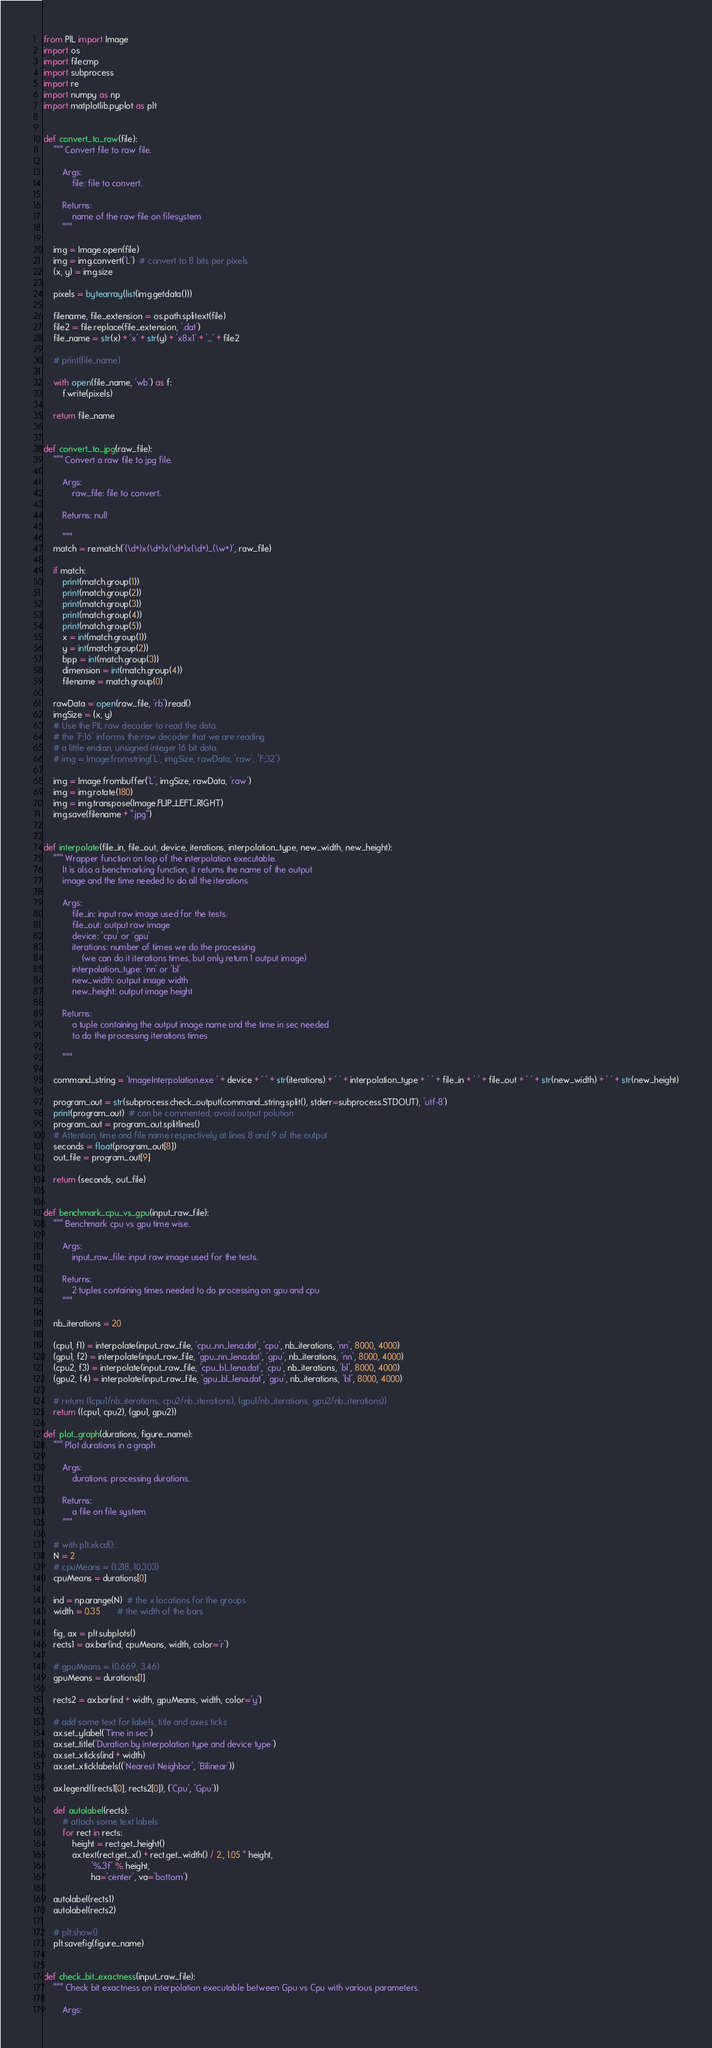Convert code to text. <code><loc_0><loc_0><loc_500><loc_500><_Python_>from PIL import Image
import os
import filecmp
import subprocess
import re
import numpy as np
import matplotlib.pyplot as plt


def convert_to_raw(file):
    """ Convert file to raw file.

        Args:
            file: file to convert.

        Returns:
            name of the raw file on filesystem
        """

    img = Image.open(file)
    img = img.convert('L')  # convert to 8 bits per pixels
    (x, y) = img.size

    pixels = bytearray(list(img.getdata()))

    filename, file_extension = os.path.splitext(file)
    file2 = file.replace(file_extension, '.dat')
    file_name = str(x) + 'x' + str(y) + 'x8x1' + '_' + file2

    # print(file_name)

    with open(file_name, 'wb') as f:
        f.write(pixels)

    return file_name


def convert_to_jpg(raw_file):
    """ Convert a raw file to jpg file.

        Args:
            raw_file: file to convert.

        Returns: null

        """
    match = re.match('(\d+)x(\d+)x(\d+)x(\d+)_(\w+)', raw_file)

    if match:
        print(match.group(1))
        print(match.group(2))
        print(match.group(3))
        print(match.group(4))
        print(match.group(5))
        x = int(match.group(1))
        y = int(match.group(2))
        bpp = int(match.group(3))
        dimension = int(match.group(4))
        filename = match.group(0)

    rawData = open(raw_file, 'rb').read()
    imgSize = (x, y)
    # Use the PIL raw decoder to read the data.
    # the 'F;16' informs the raw decoder that we are reading
    # a little endian, unsigned integer 16 bit data.
    # img = Image.fromstring('L', imgSize, rawData, 'raw', 'F;32')

    img = Image.frombuffer('L', imgSize, rawData, 'raw')
    img = img.rotate(180)
    img = img.transpose(Image.FLIP_LEFT_RIGHT)
    img.save(filename + ".jpg")


def interpolate(file_in, file_out, device, iterations, interpolation_type, new_width, new_height):
    """ Wrapper function on top of the interpolation executable.
        It is also a benchmarking function, it returns the name of the output
        image and the time needed to do all the iterations

        Args:
            file_in: input raw image used for the tests.
            file_out: output raw image
            device: 'cpu' or 'gpu'
            iterations: number of times we do the processing
                (we can do it iterations times, but only return 1 output image)
            interpolation_type: 'nn' or 'bl'
            new_width: output image width
            new_height: output image height

        Returns:
            a tuple containing the output image name and the time in sec needed
            to do the processing iterations times

        """

    command_string = 'ImageInterpolation.exe ' + device + ' ' + str(iterations) + ' ' + interpolation_type + ' ' + file_in + ' ' + file_out + ' ' + str(new_width) + ' ' + str(new_height)

    program_out = str(subprocess.check_output(command_string.split(), stderr=subprocess.STDOUT), 'utf-8')
    print(program_out)  # can be commented, avoid output polution
    program_out = program_out.splitlines()
    # Attention, time and file name respectively at lines 8 and 9 of the output
    seconds = float(program_out[8])
    out_file = program_out[9]

    return (seconds, out_file)


def benchmark_cpu_vs_gpu(input_raw_file):
    """ Benchmark cpu vs gpu time wise.

        Args:
            input_raw_file: input raw image used for the tests.

        Returns:
            2 tuples containing times needed to do processing on gpu and cpu
        """

    nb_iterations = 20

    (cpu1, f1) = interpolate(input_raw_file, 'cpu_nn_lena.dat', 'cpu', nb_iterations, 'nn', 8000, 4000)
    (gpu1, f2) = interpolate(input_raw_file, 'gpu_nn_lena.dat', 'gpu', nb_iterations, 'nn', 8000, 4000)
    (cpu2, f3) = interpolate(input_raw_file, 'cpu_bl_lena.dat', 'cpu', nb_iterations, 'bl', 8000, 4000)
    (gpu2, f4) = interpolate(input_raw_file, 'gpu_bl_lena.dat', 'gpu', nb_iterations, 'bl', 8000, 4000)

    # return ((cpu1/nb_iterations, cpu2/nb_iterations), (gpu1/nb_iterations, gpu2/nb_iterations))
    return ((cpu1, cpu2), (gpu1, gpu2))

def plot_graph(durations, figure_name):
    """ Plot durations in a graph

        Args:
            durations: processing durations.

        Returns:
            a file on file system
        """

    # with plt.xkcd():
    N = 2
    # cpuMeans = (1.218, 10.303)
    cpuMeans = durations[0]

    ind = np.arange(N)  # the x locations for the groups
    width = 0.35       # the width of the bars

    fig, ax = plt.subplots()
    rects1 = ax.bar(ind, cpuMeans, width, color='r')

    # gpuMeans = (0.669, 3.46)
    gpuMeans = durations[1]

    rects2 = ax.bar(ind + width, gpuMeans, width, color='y')

    # add some text for labels, title and axes ticks
    ax.set_ylabel('Time in sec')
    ax.set_title('Duration by interpolation type and device type')
    ax.set_xticks(ind + width)
    ax.set_xticklabels(('Nearest Neighbor', 'Bilinear'))

    ax.legend((rects1[0], rects2[0]), ('Cpu', 'Gpu'))

    def autolabel(rects):
        # attach some text labels
        for rect in rects:
            height = rect.get_height()
            ax.text(rect.get_x() + rect.get_width() / 2., 1.05 * height,
                    '%.3f' % height,
                    ha='center', va='bottom')

    autolabel(rects1)
    autolabel(rects2)

    # plt.show()
    plt.savefig(figure_name)


def check_bit_exactness(input_raw_file):
    """ Check bit exactness on interpolation executable between Gpu vs Cpu with various parameters.

        Args:</code> 